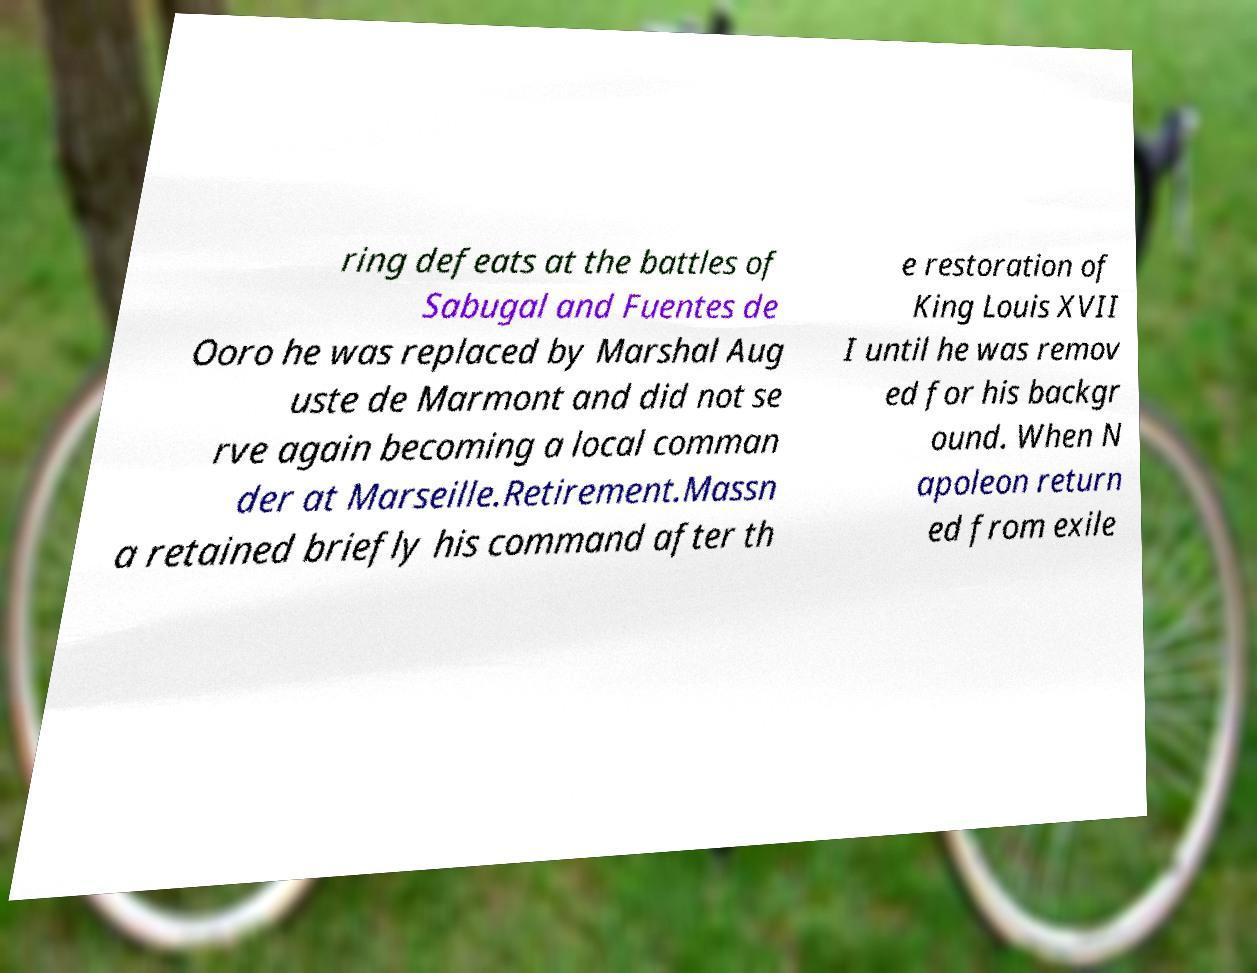Can you read and provide the text displayed in the image?This photo seems to have some interesting text. Can you extract and type it out for me? ring defeats at the battles of Sabugal and Fuentes de Ooro he was replaced by Marshal Aug uste de Marmont and did not se rve again becoming a local comman der at Marseille.Retirement.Massn a retained briefly his command after th e restoration of King Louis XVII I until he was remov ed for his backgr ound. When N apoleon return ed from exile 